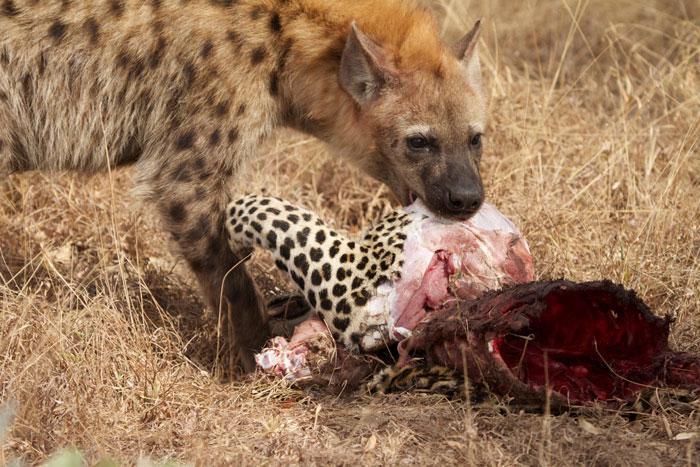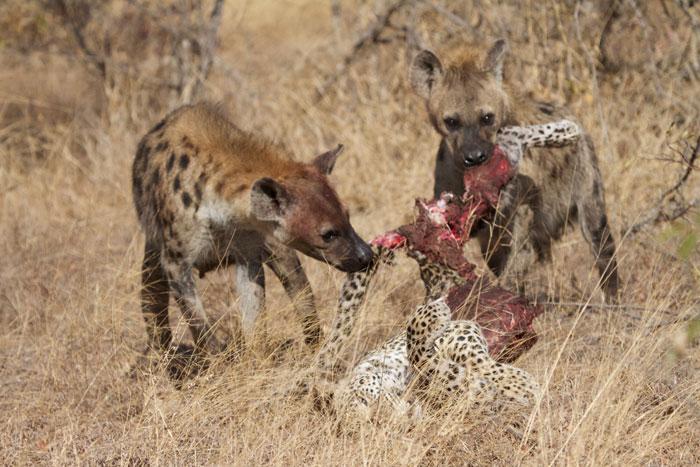The first image is the image on the left, the second image is the image on the right. Evaluate the accuracy of this statement regarding the images: "There are atleast 4 Hyenas total". Is it true? Answer yes or no. No. The first image is the image on the left, the second image is the image on the right. Assess this claim about the two images: "At least one image includes two hyenas fighting each other, with some bared fangs showing.". Correct or not? Answer yes or no. No. 